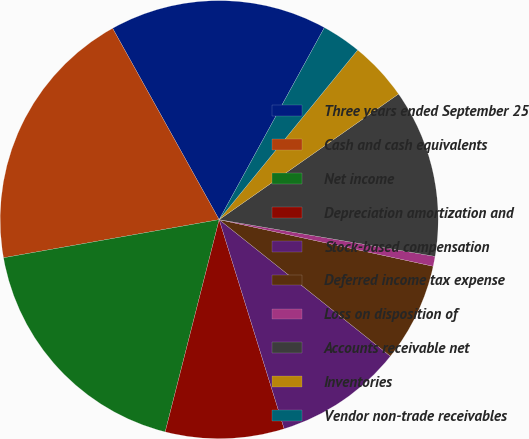Convert chart. <chart><loc_0><loc_0><loc_500><loc_500><pie_chart><fcel>Three years ended September 25<fcel>Cash and cash equivalents<fcel>Net income<fcel>Depreciation amortization and<fcel>Stock-based compensation<fcel>Deferred income tax expense<fcel>Loss on disposition of<fcel>Accounts receivable net<fcel>Inventories<fcel>Vendor non-trade receivables<nl><fcel>16.06%<fcel>19.7%<fcel>18.25%<fcel>8.76%<fcel>9.49%<fcel>7.3%<fcel>0.73%<fcel>12.41%<fcel>4.38%<fcel>2.92%<nl></chart> 